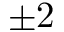Convert formula to latex. <formula><loc_0><loc_0><loc_500><loc_500>\pm 2</formula> 